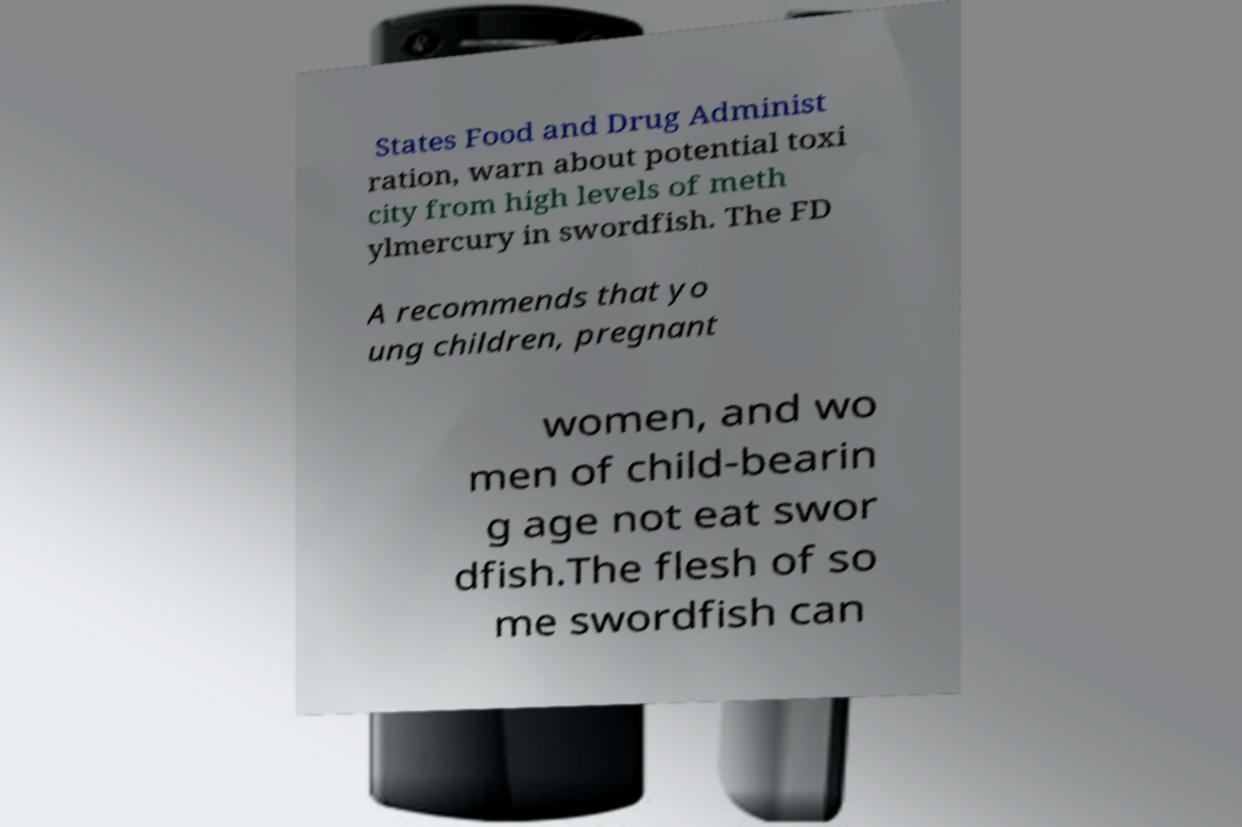Can you accurately transcribe the text from the provided image for me? States Food and Drug Administ ration, warn about potential toxi city from high levels of meth ylmercury in swordfish. The FD A recommends that yo ung children, pregnant women, and wo men of child-bearin g age not eat swor dfish.The flesh of so me swordfish can 